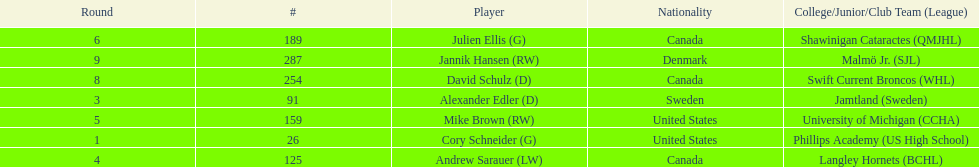How many players are from the united states? 2. Parse the full table. {'header': ['Round', '#', 'Player', 'Nationality', 'College/Junior/Club Team (League)'], 'rows': [['6', '189', 'Julien Ellis (G)', 'Canada', 'Shawinigan Cataractes (QMJHL)'], ['9', '287', 'Jannik Hansen (RW)', 'Denmark', 'Malmö Jr. (SJL)'], ['8', '254', 'David Schulz (D)', 'Canada', 'Swift Current Broncos (WHL)'], ['3', '91', 'Alexander Edler (D)', 'Sweden', 'Jamtland (Sweden)'], ['5', '159', 'Mike Brown (RW)', 'United States', 'University of Michigan (CCHA)'], ['1', '26', 'Cory Schneider (G)', 'United States', 'Phillips Academy (US High School)'], ['4', '125', 'Andrew Sarauer (LW)', 'Canada', 'Langley Hornets (BCHL)']]} 